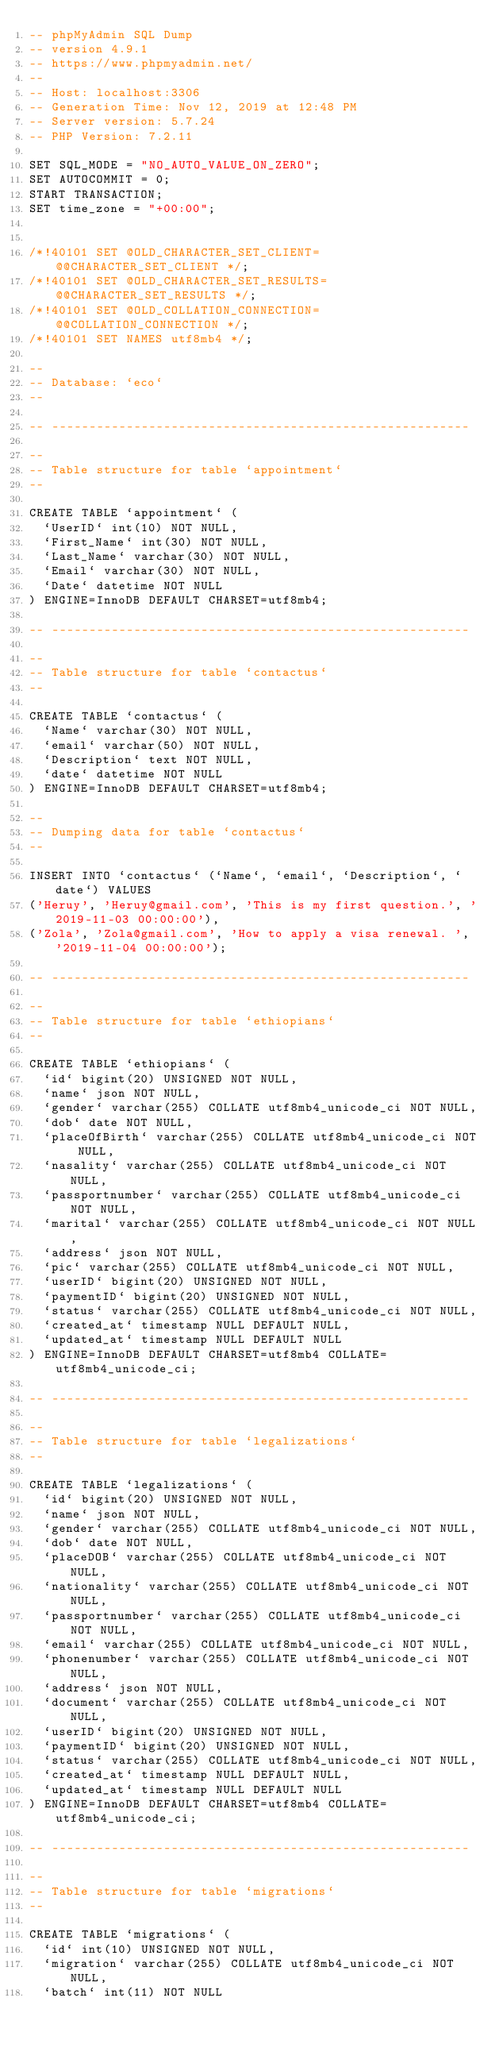Convert code to text. <code><loc_0><loc_0><loc_500><loc_500><_SQL_>-- phpMyAdmin SQL Dump
-- version 4.9.1
-- https://www.phpmyadmin.net/
--
-- Host: localhost:3306
-- Generation Time: Nov 12, 2019 at 12:48 PM
-- Server version: 5.7.24
-- PHP Version: 7.2.11

SET SQL_MODE = "NO_AUTO_VALUE_ON_ZERO";
SET AUTOCOMMIT = 0;
START TRANSACTION;
SET time_zone = "+00:00";


/*!40101 SET @OLD_CHARACTER_SET_CLIENT=@@CHARACTER_SET_CLIENT */;
/*!40101 SET @OLD_CHARACTER_SET_RESULTS=@@CHARACTER_SET_RESULTS */;
/*!40101 SET @OLD_COLLATION_CONNECTION=@@COLLATION_CONNECTION */;
/*!40101 SET NAMES utf8mb4 */;

--
-- Database: `eco`
--

-- --------------------------------------------------------

--
-- Table structure for table `appointment`
--

CREATE TABLE `appointment` (
  `UserID` int(10) NOT NULL,
  `First_Name` int(30) NOT NULL,
  `Last_Name` varchar(30) NOT NULL,
  `Email` varchar(30) NOT NULL,
  `Date` datetime NOT NULL
) ENGINE=InnoDB DEFAULT CHARSET=utf8mb4;

-- --------------------------------------------------------

--
-- Table structure for table `contactus`
--

CREATE TABLE `contactus` (
  `Name` varchar(30) NOT NULL,
  `email` varchar(50) NOT NULL,
  `Description` text NOT NULL,
  `date` datetime NOT NULL
) ENGINE=InnoDB DEFAULT CHARSET=utf8mb4;

--
-- Dumping data for table `contactus`
--

INSERT INTO `contactus` (`Name`, `email`, `Description`, `date`) VALUES
('Heruy', 'Heruy@gmail.com', 'This is my first question.', '2019-11-03 00:00:00'),
('Zola', 'Zola@gmail.com', 'How to apply a visa renewal. ', '2019-11-04 00:00:00');

-- --------------------------------------------------------

--
-- Table structure for table `ethiopians`
--

CREATE TABLE `ethiopians` (
  `id` bigint(20) UNSIGNED NOT NULL,
  `name` json NOT NULL,
  `gender` varchar(255) COLLATE utf8mb4_unicode_ci NOT NULL,
  `dob` date NOT NULL,
  `placeOfBirth` varchar(255) COLLATE utf8mb4_unicode_ci NOT NULL,
  `nasality` varchar(255) COLLATE utf8mb4_unicode_ci NOT NULL,
  `passportnumber` varchar(255) COLLATE utf8mb4_unicode_ci NOT NULL,
  `marital` varchar(255) COLLATE utf8mb4_unicode_ci NOT NULL,
  `address` json NOT NULL,
  `pic` varchar(255) COLLATE utf8mb4_unicode_ci NOT NULL,
  `userID` bigint(20) UNSIGNED NOT NULL,
  `paymentID` bigint(20) UNSIGNED NOT NULL,
  `status` varchar(255) COLLATE utf8mb4_unicode_ci NOT NULL,
  `created_at` timestamp NULL DEFAULT NULL,
  `updated_at` timestamp NULL DEFAULT NULL
) ENGINE=InnoDB DEFAULT CHARSET=utf8mb4 COLLATE=utf8mb4_unicode_ci;

-- --------------------------------------------------------

--
-- Table structure for table `legalizations`
--

CREATE TABLE `legalizations` (
  `id` bigint(20) UNSIGNED NOT NULL,
  `name` json NOT NULL,
  `gender` varchar(255) COLLATE utf8mb4_unicode_ci NOT NULL,
  `dob` date NOT NULL,
  `placeDOB` varchar(255) COLLATE utf8mb4_unicode_ci NOT NULL,
  `nationality` varchar(255) COLLATE utf8mb4_unicode_ci NOT NULL,
  `passportnumber` varchar(255) COLLATE utf8mb4_unicode_ci NOT NULL,
  `email` varchar(255) COLLATE utf8mb4_unicode_ci NOT NULL,
  `phonenumber` varchar(255) COLLATE utf8mb4_unicode_ci NOT NULL,
  `address` json NOT NULL,
  `document` varchar(255) COLLATE utf8mb4_unicode_ci NOT NULL,
  `userID` bigint(20) UNSIGNED NOT NULL,
  `paymentID` bigint(20) UNSIGNED NOT NULL,
  `status` varchar(255) COLLATE utf8mb4_unicode_ci NOT NULL,
  `created_at` timestamp NULL DEFAULT NULL,
  `updated_at` timestamp NULL DEFAULT NULL
) ENGINE=InnoDB DEFAULT CHARSET=utf8mb4 COLLATE=utf8mb4_unicode_ci;

-- --------------------------------------------------------

--
-- Table structure for table `migrations`
--

CREATE TABLE `migrations` (
  `id` int(10) UNSIGNED NOT NULL,
  `migration` varchar(255) COLLATE utf8mb4_unicode_ci NOT NULL,
  `batch` int(11) NOT NULL</code> 